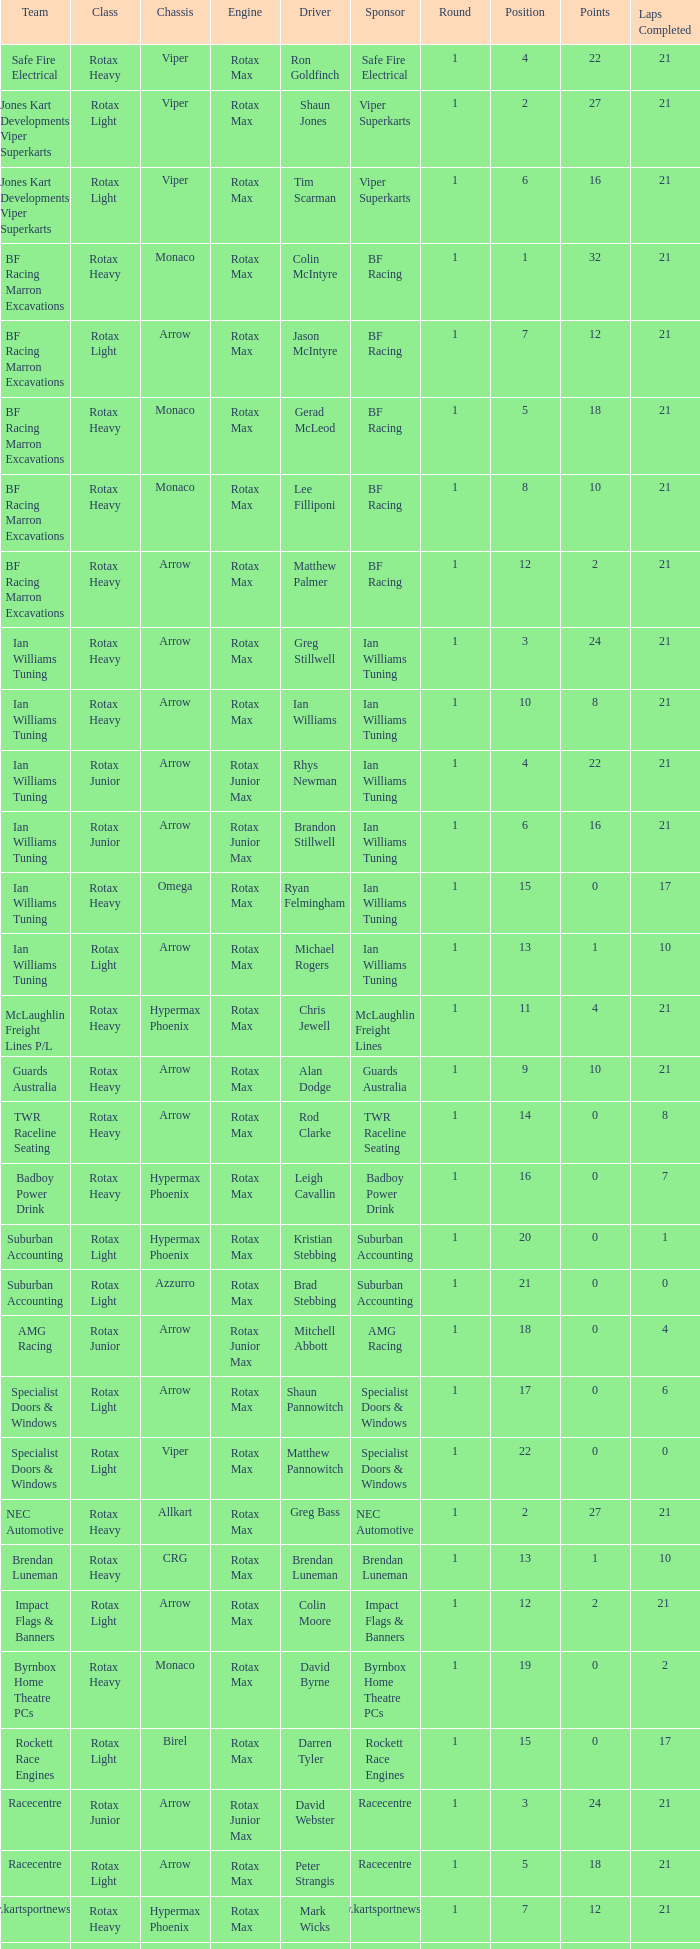What type of engine does the BF Racing Marron Excavations have that also has Monaco as chassis and Lee Filliponi as the driver? Rotax Max. 